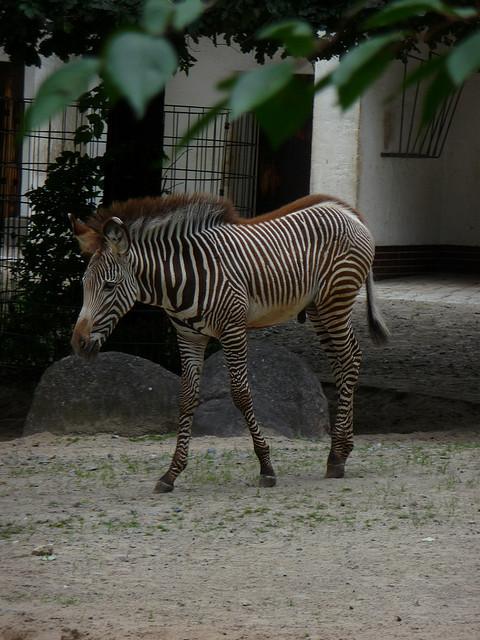How many zebras are pictured?
Give a very brief answer. 1. What color mane do they have?
Short answer required. Brown. What color is the zebra's mohawk?
Write a very short answer. Brown. What color is the zebra?
Write a very short answer. Black and white. Is the animal reacting weird?
Write a very short answer. No. Is the zebra sleeping?
Short answer required. No. Which animal is this?
Quick response, please. Zebra. Is the animal young or old?
Write a very short answer. Young. Do zebras walk in snow?
Quick response, please. No. How many zebras are there in the picture?
Quick response, please. 1. 